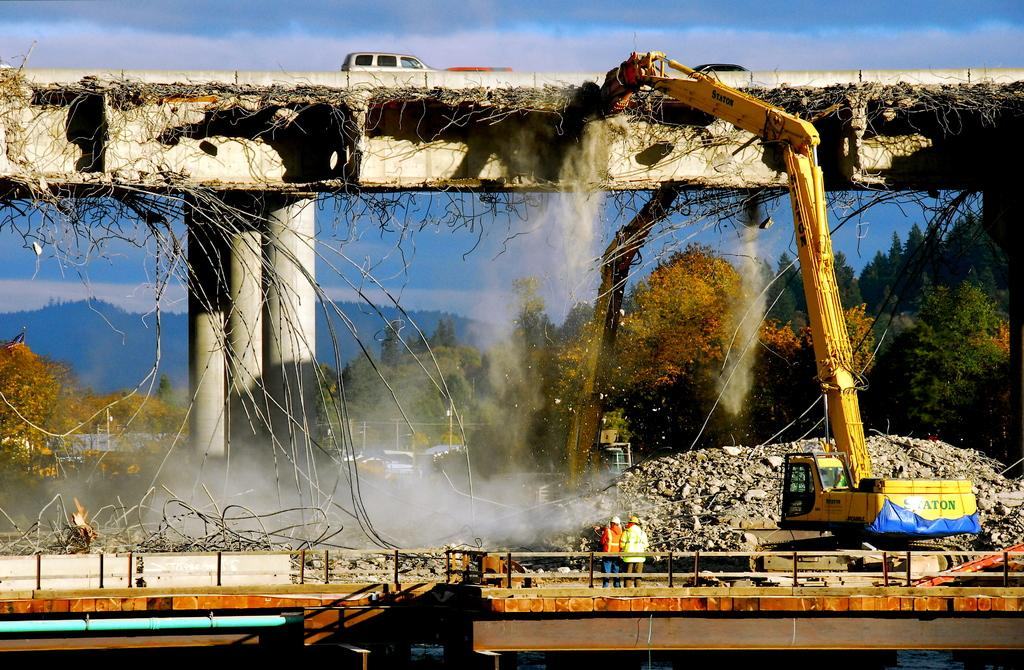What type of structure can be seen in the image? There is a bridge in the image. What is on the bridge? A car is present on the bridge. What natural features are visible in the image? There are mountains visible in the image. What type of vehicles are in the image besides the car? There are tractors in the image. What is visible at the top of the image? The sky is visible at the top of the image. What type of pets can be seen visiting the learning center in the image? There is no learning center or pets present in the image. 